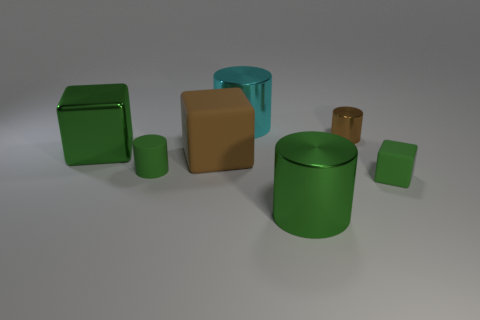Does the small block have the same color as the rubber cylinder?
Ensure brevity in your answer.  Yes. Is there a cyan shiny ball?
Offer a very short reply. No. There is a green metal object that is behind the large metal cylinder in front of the large brown matte thing left of the cyan metal cylinder; what is its shape?
Keep it short and to the point. Cube. What number of things are in front of the tiny brown object?
Give a very brief answer. 5. Are the thing that is to the right of the small shiny cylinder and the big brown object made of the same material?
Give a very brief answer. Yes. What number of other objects are the same shape as the large cyan thing?
Give a very brief answer. 3. What number of small brown objects are left of the green cylinder that is behind the small object on the right side of the tiny brown thing?
Offer a very short reply. 0. What color is the shiny cylinder to the right of the green shiny cylinder?
Make the answer very short. Brown. Is the color of the rubber block that is behind the tiny green block the same as the small shiny thing?
Offer a terse response. Yes. What is the size of the green metallic object that is the same shape as the large cyan metal object?
Your answer should be compact. Large. 